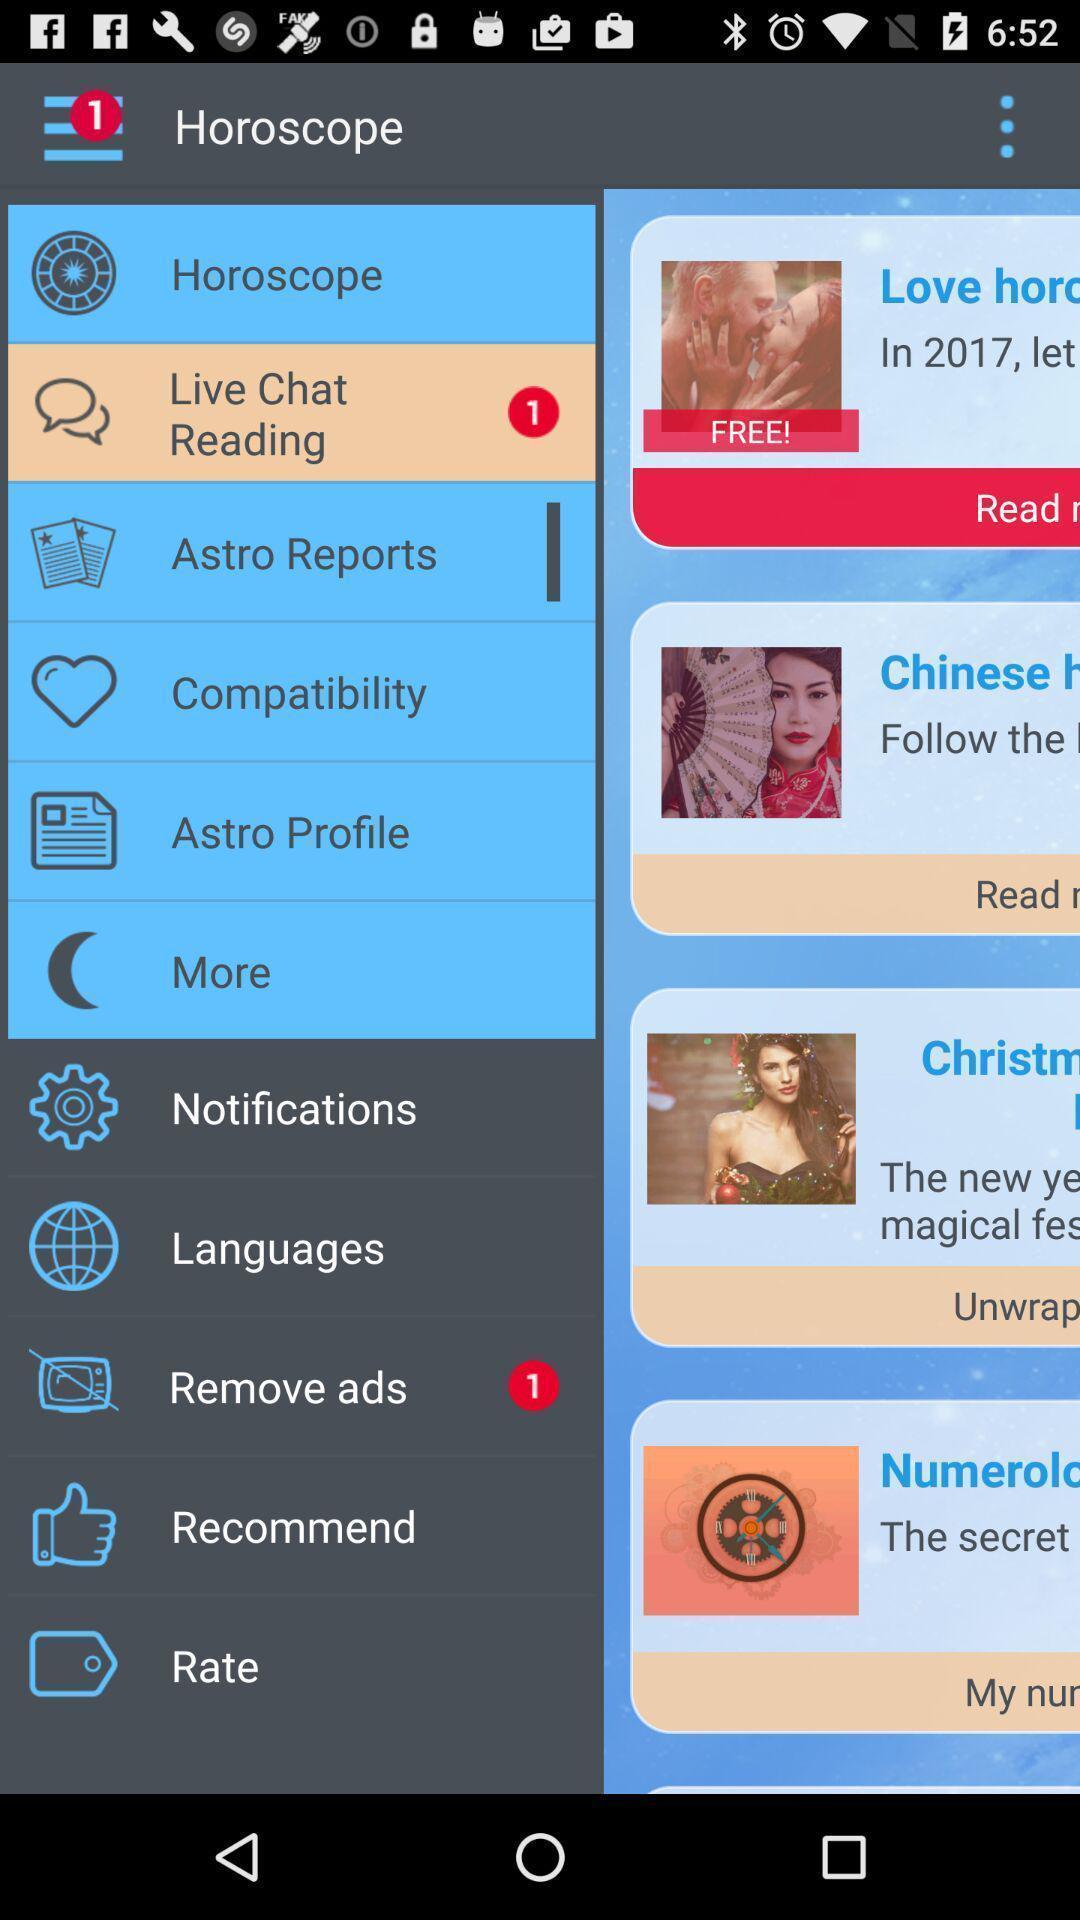Provide a textual representation of this image. Page displaying different options available in astrology application. 